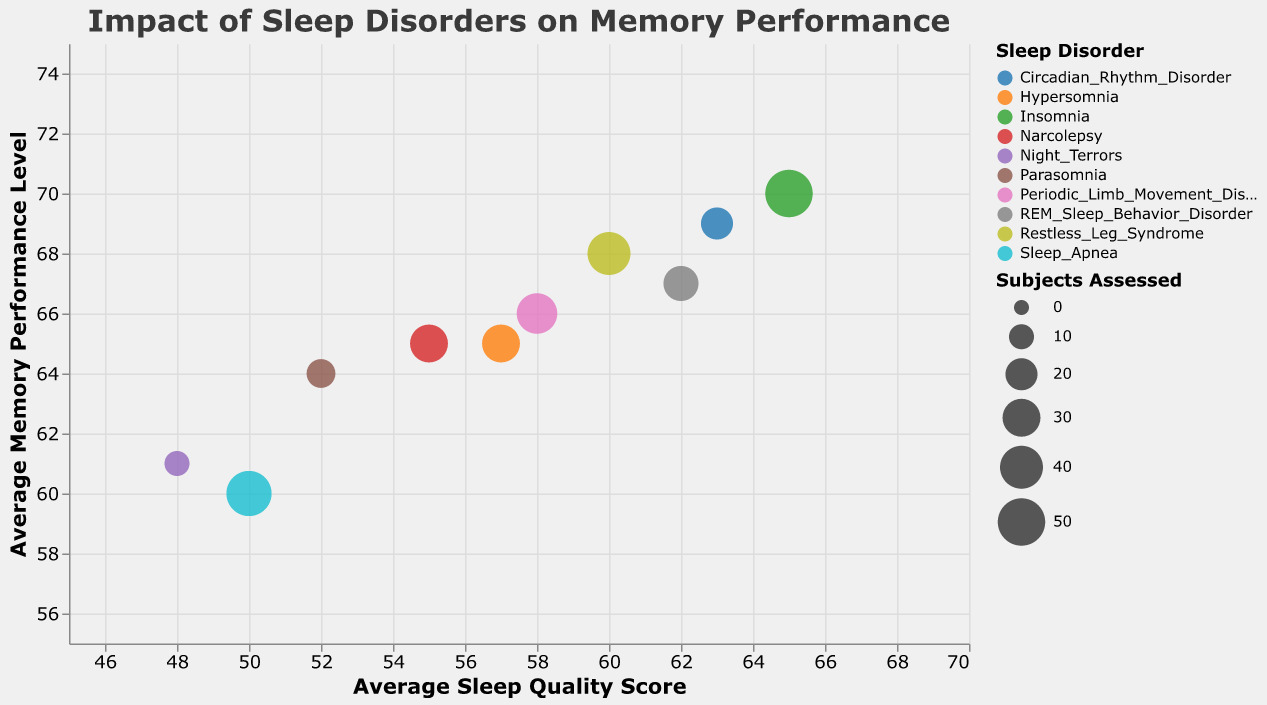How many different types of sleep disorders are represented in the chart? Count the unique sleep disorders listed in the legend. Each color represents a different sleep disorder.
Answer: 10 What is the average sleep quality score for Insomnia? Find the data point representing Insomnia on the x-axis and note its x-coordinate.
Answer: 65 Which sleep disorder has the highest average memory performance level? Compare the y-coordinate of each sleep disorder and find the maximum value. The sleep disorder corresponding to this highest y-coordinate has the highest average memory performance.
Answer: Insomnia What is the difference in average sleep quality score between Insomnia and Sleep Apnea? Find the x-coordinates of Insomnia and Sleep Apnea and calculate the difference: 65 (Insomnia) - 50 (Sleep Apnea).
Answer: 15 Which sleep disorder has the least number of subjects assessed? Compare the sizes of the bubbles and find the smallest one. The sleep disorder corresponding to this smallest bubble has the least number of subjects assessed.
Answer: Night Terrors How does the average sleep quality score for Restless Leg Syndrome compare to Circadian Rhythm Disorder? Locate the bubbles for Restless Leg Syndrome and Circadian Rhythm Disorder on the x-axis and compare their x-coordinates: 60 (Restless Leg Syndrome) versus 63 (Circadian Rhythm Disorder).
Answer: Lower Which sleep disorder has a larger assessed subject size: Narcolepsy or Periodic Limb Movement Disorder? Compare the bubble sizes for Narcolepsy and Periodic Limb Movement Disorder. The larger bubble indicates more subjects assessed.
Answer: Narcolepsy Evaluate if there is any sleep disorder with an average sleep quality score below 50. Check each bubble's x-coordinate to see if any are positioned below the 50 mark on the x-axis.
Answer: Yes, Night Terrors What is the range of average memory performance levels for the sleep disorders represented? Find the minimum and maximum y-coordinates among all bubbles. Minimum: 60 (Sleep Apnea); Maximum: 70 (Insomnia). Calculate the range: 70 - 60.
Answer: 10 